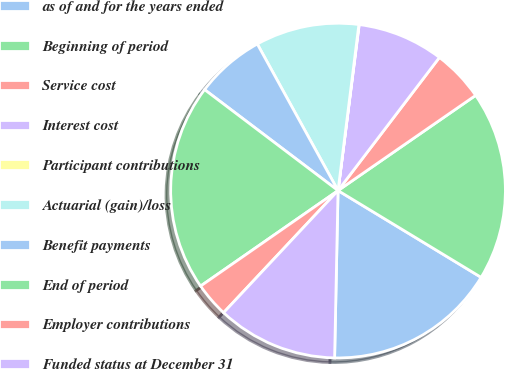Convert chart. <chart><loc_0><loc_0><loc_500><loc_500><pie_chart><fcel>as of and for the years ended<fcel>Beginning of period<fcel>Service cost<fcel>Interest cost<fcel>Participant contributions<fcel>Actuarial (gain)/loss<fcel>Benefit payments<fcel>End of period<fcel>Employer contributions<fcel>Funded status at December 31<nl><fcel>16.65%<fcel>18.31%<fcel>5.01%<fcel>8.34%<fcel>0.03%<fcel>10.0%<fcel>6.68%<fcel>19.97%<fcel>3.35%<fcel>11.66%<nl></chart> 